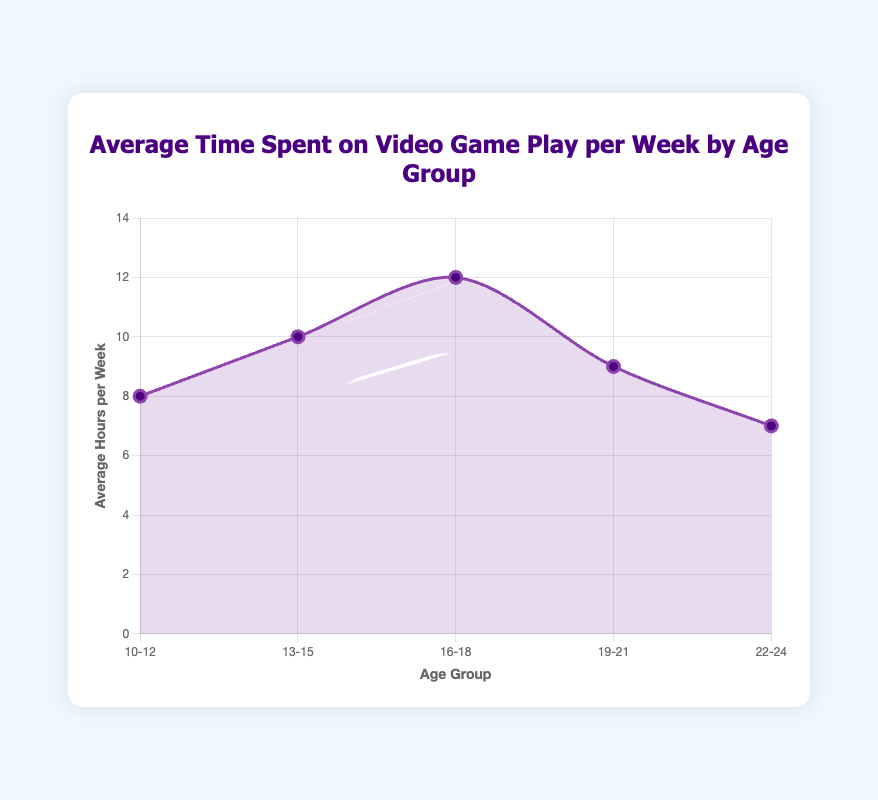What age group spends the most time on video games per week? The highest average number of hours per week is observed at the data point with the highest value on the y-axis. This corresponds to the age group 16-18, with an average of 12 hours per week.
Answer: 16-18 Which age group spends less time on video games per week, 10-12 or 22-24? Looking at the values for these age groups, 10-12 spends 8 hours per week while 22-24 spends 7 hours per week. The 22-24 age group spends less time.
Answer: 22-24 What's the difference in average hours spent per week on video games between the age groups 13-15 and 19-21? The average hours for 13-15 is 10 and for 19-21 is 9. The difference is 10 - 9, which is 1 hour.
Answer: 1 hour What is the average time spent on video games per week for the age groups 10-12, 13-15, and 16-18 combined? Calculate the average by adding the hours of each group (8 + 10 + 12) and then dividing by the number of groups (3). (8 + 10 + 12) / 3 equals 10 hours.
Answer: 10 hours Which two age groups show the biggest change in average time spent on video games per week? Observing the differences between adjacent age groups: 10-12 to 13-15 is 2 hours, 13-15 to 16-18 is 2 hours, 16-18 to 19-21 is 3 hours, and 19-21 to 22-24 is 2 hours. The largest change is between 16-18 and 19-21 with a 3-hour difference.
Answer: 16-18 and 19-21 What is the overall trend in average time spent on video games from youngest to oldest age group? The trend shows an increase in hours from 10-12 to 16-18, peaking at 16-18. It then decreases from 16-18 onwards.
Answer: Increase then decrease How does the average time spent on video games for 19-21 compare to that of 16-18? The 19-21 age group spends 9 hours per week, while the 16-18 age group spends 12 hours. 19-21 spends 3 hours less than 16-18.
Answer: 3 hours less What is the average time spent on video games per week for all age groups? Calculate the average by summing all hours (8 + 10 + 12 + 9 + 7) and dividing by the number of age groups (5). (8 + 10 + 12 + 9 + 7) / 5 equals 9.2 hours.
Answer: 9.2 hours Which age group spends an equal amount of time on video games as the difference between the time spent by ages 13-15 and 22-24? The difference between 13-15 (10 hours) and 22-24 (7 hours) is 3 hours. None of the age groups spend exactly 3 hours per week on video games.
Answer: None 